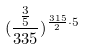<formula> <loc_0><loc_0><loc_500><loc_500>( \frac { \frac { 3 } { 5 } } { 3 3 5 } ) ^ { \frac { 3 1 5 } { 2 } \cdot 5 }</formula> 